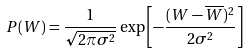<formula> <loc_0><loc_0><loc_500><loc_500>P ( W ) = \frac { 1 } { \sqrt { 2 \pi \sigma ^ { 2 } } } \exp \left [ - \frac { ( W - \overline { W } ) ^ { 2 } } { 2 \sigma ^ { 2 } } \right ]</formula> 